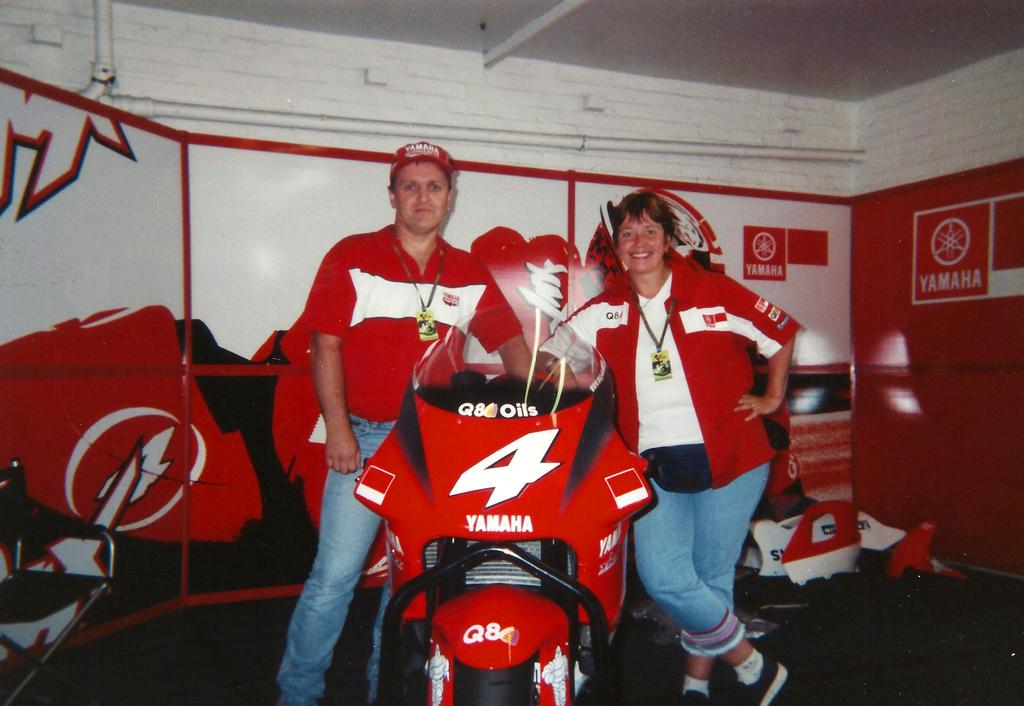Provide a one-sentence caption for the provided image. Yamaha is the corporate sponsor for the racing bike. 